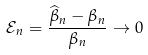<formula> <loc_0><loc_0><loc_500><loc_500>\mathcal { E } _ { n } = \frac { \widehat { \beta } _ { n } - \beta _ { n } } { \beta _ { n } } \rightarrow 0</formula> 